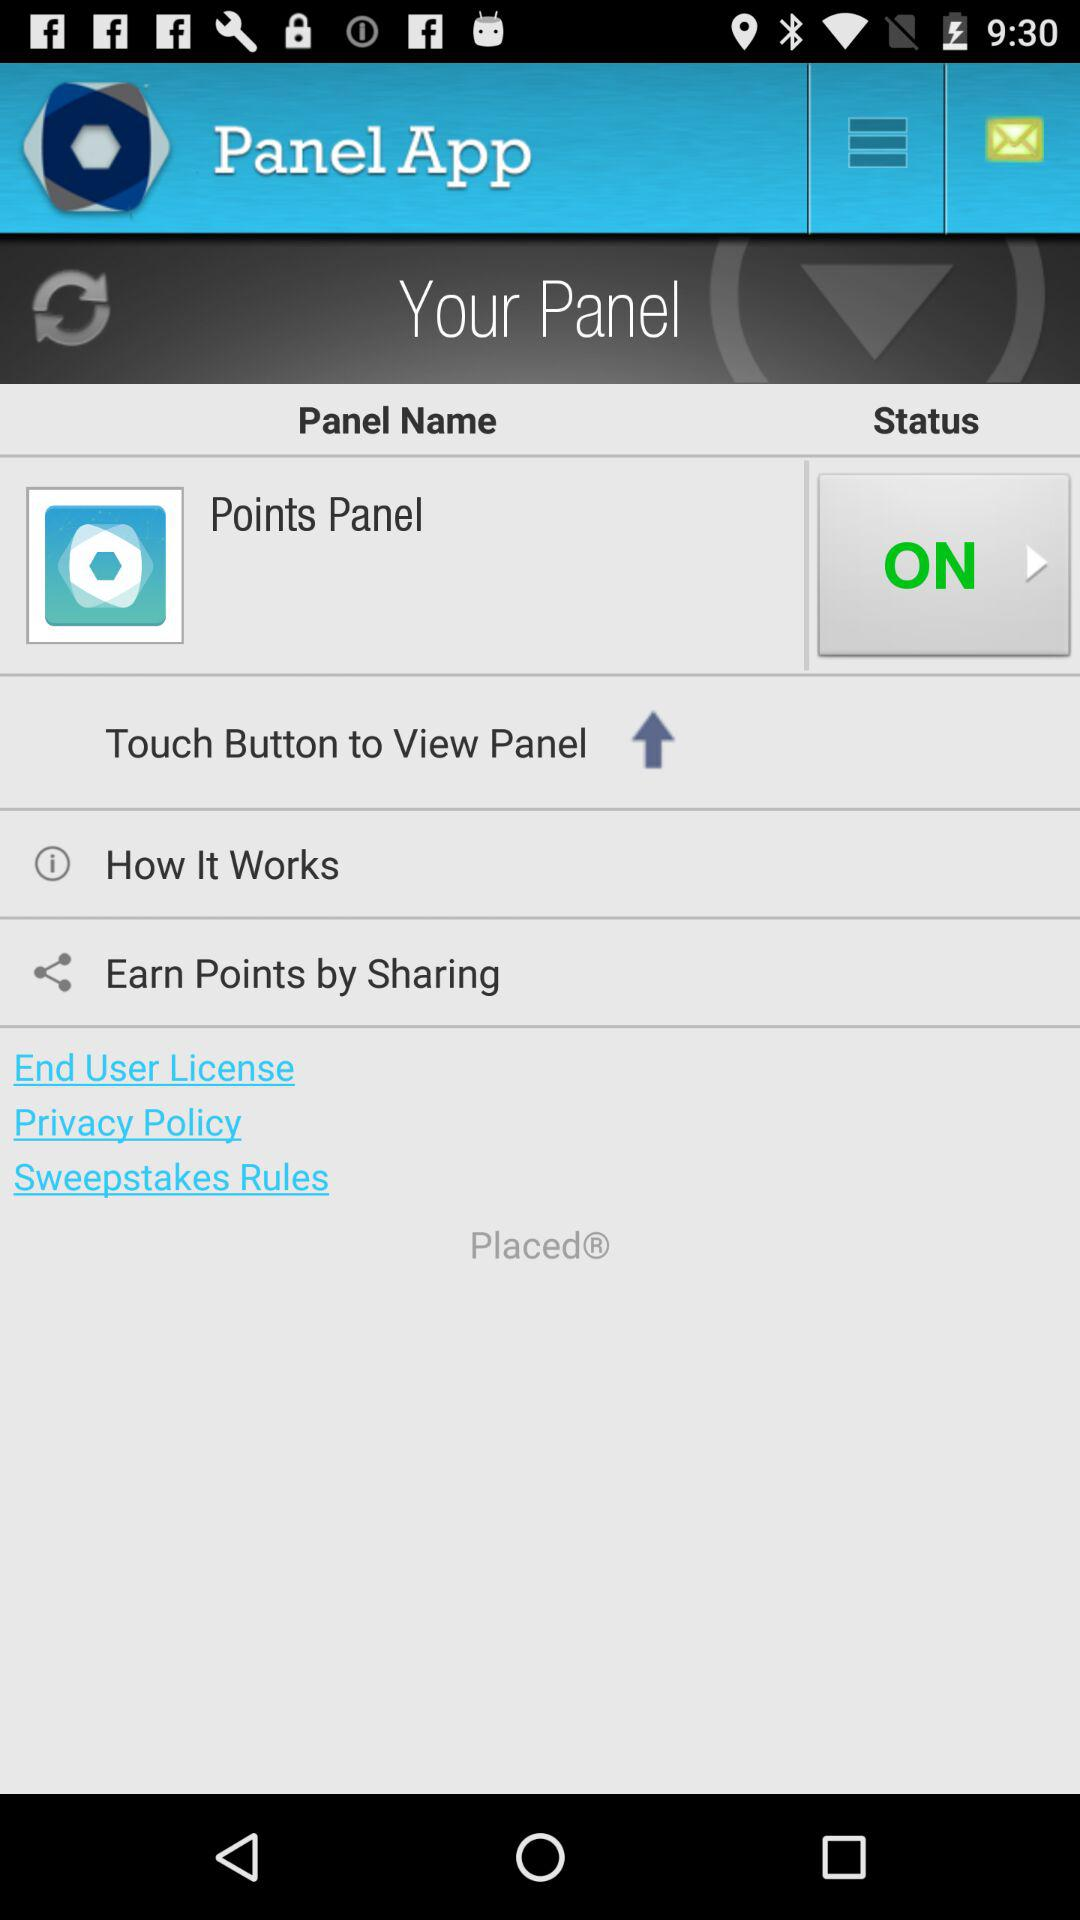How many navigation items are there on the screen?
Answer the question using a single word or phrase. 3 